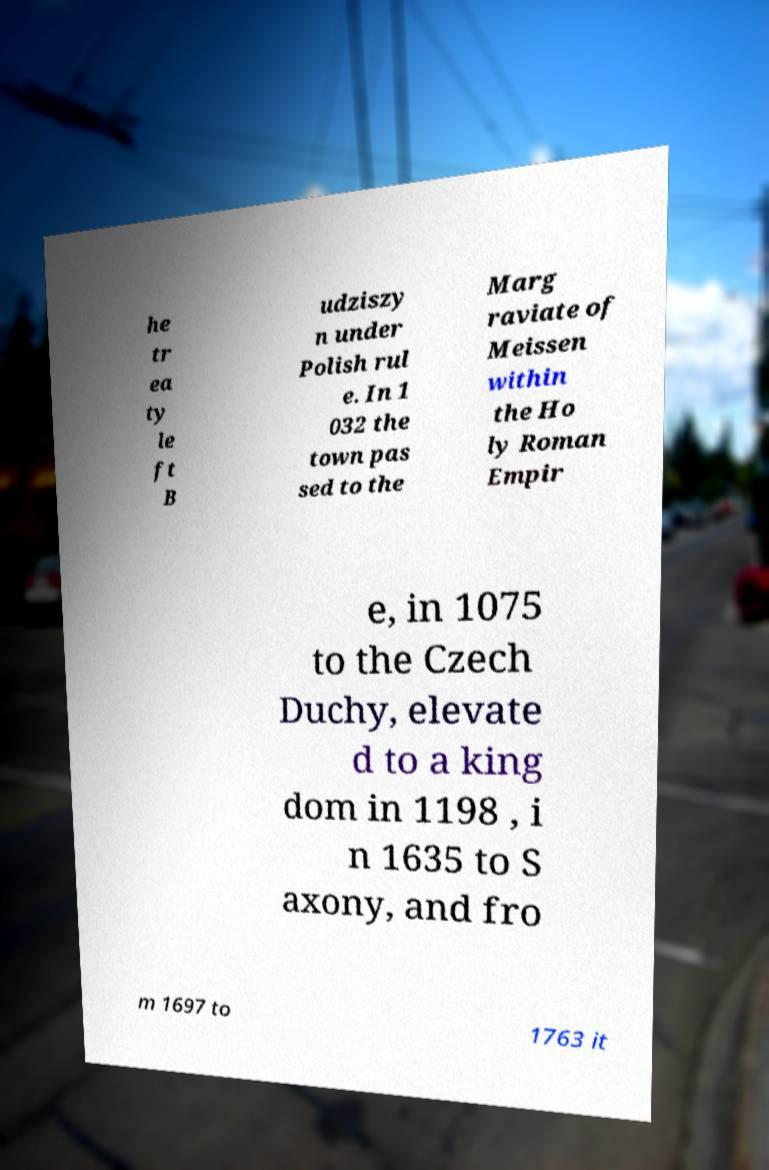Please identify and transcribe the text found in this image. he tr ea ty le ft B udziszy n under Polish rul e. In 1 032 the town pas sed to the Marg raviate of Meissen within the Ho ly Roman Empir e, in 1075 to the Czech Duchy, elevate d to a king dom in 1198 , i n 1635 to S axony, and fro m 1697 to 1763 it 